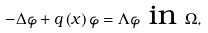<formula> <loc_0><loc_0><loc_500><loc_500>- \Delta \varphi + q \left ( x \right ) \varphi = \Lambda \varphi \text { in } \Omega ,</formula> 